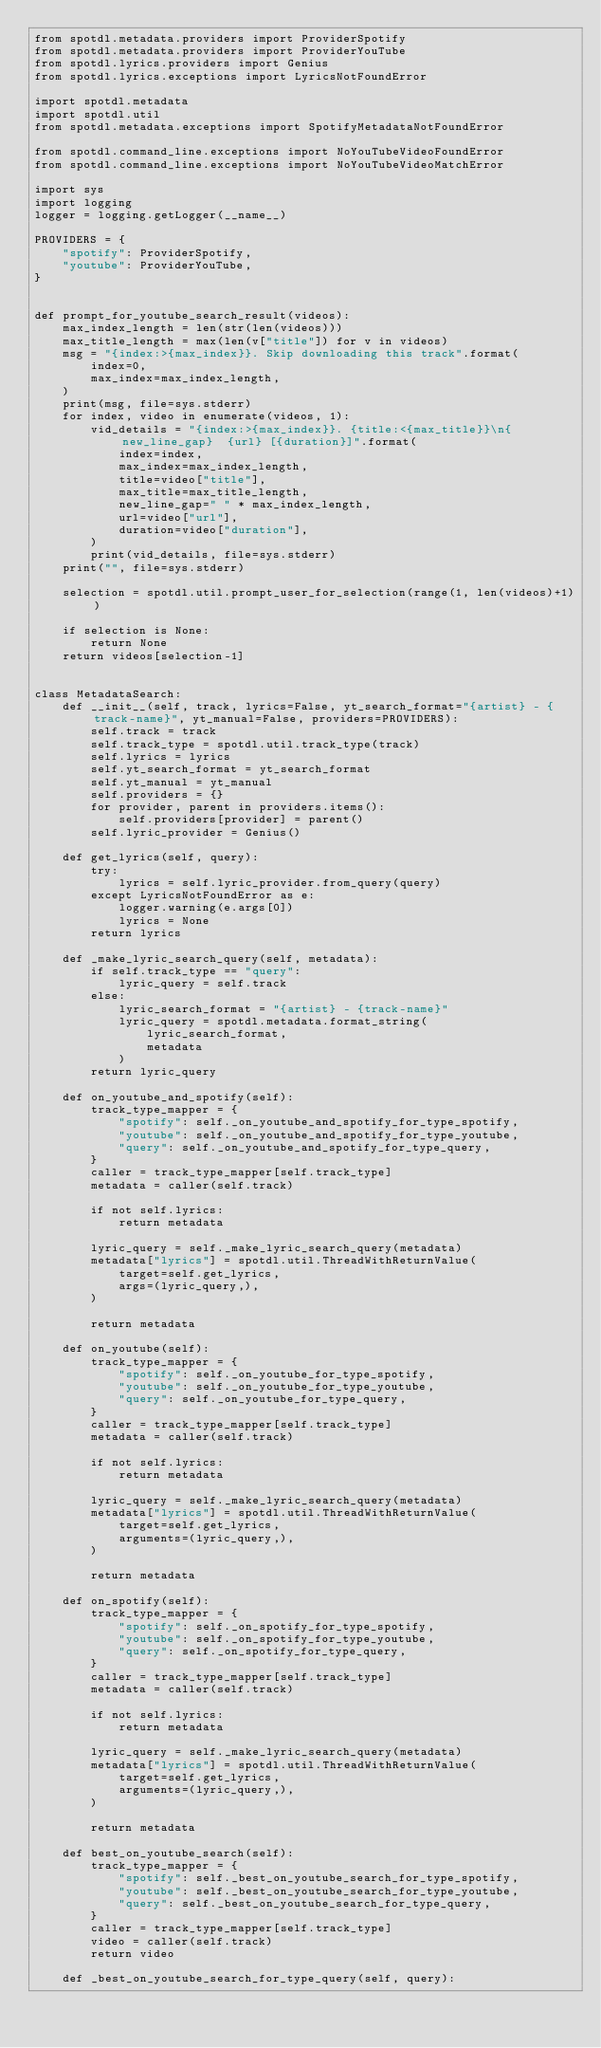Convert code to text. <code><loc_0><loc_0><loc_500><loc_500><_Python_>from spotdl.metadata.providers import ProviderSpotify
from spotdl.metadata.providers import ProviderYouTube
from spotdl.lyrics.providers import Genius
from spotdl.lyrics.exceptions import LyricsNotFoundError

import spotdl.metadata
import spotdl.util
from spotdl.metadata.exceptions import SpotifyMetadataNotFoundError

from spotdl.command_line.exceptions import NoYouTubeVideoFoundError
from spotdl.command_line.exceptions import NoYouTubeVideoMatchError

import sys
import logging
logger = logging.getLogger(__name__)

PROVIDERS = {
    "spotify": ProviderSpotify,
    "youtube": ProviderYouTube,
}


def prompt_for_youtube_search_result(videos):
    max_index_length = len(str(len(videos)))
    max_title_length = max(len(v["title"]) for v in videos)
    msg = "{index:>{max_index}}. Skip downloading this track".format(
        index=0,
        max_index=max_index_length,
    )
    print(msg, file=sys.stderr)
    for index, video in enumerate(videos, 1):
        vid_details = "{index:>{max_index}}. {title:<{max_title}}\n{new_line_gap}  {url} [{duration}]".format(
            index=index,
            max_index=max_index_length,
            title=video["title"],
            max_title=max_title_length,
            new_line_gap=" " * max_index_length,
            url=video["url"],
            duration=video["duration"],
        )
        print(vid_details, file=sys.stderr)
    print("", file=sys.stderr)

    selection = spotdl.util.prompt_user_for_selection(range(1, len(videos)+1))

    if selection is None:
        return None
    return videos[selection-1]


class MetadataSearch:
    def __init__(self, track, lyrics=False, yt_search_format="{artist} - {track-name}", yt_manual=False, providers=PROVIDERS):
        self.track = track
        self.track_type = spotdl.util.track_type(track)
        self.lyrics = lyrics
        self.yt_search_format = yt_search_format
        self.yt_manual = yt_manual
        self.providers = {}
        for provider, parent in providers.items():
            self.providers[provider] = parent()
        self.lyric_provider = Genius()

    def get_lyrics(self, query):
        try:
            lyrics = self.lyric_provider.from_query(query)
        except LyricsNotFoundError as e:
            logger.warning(e.args[0])
            lyrics = None
        return lyrics

    def _make_lyric_search_query(self, metadata):
        if self.track_type == "query":
            lyric_query = self.track
        else:
            lyric_search_format = "{artist} - {track-name}"
            lyric_query = spotdl.metadata.format_string(
                lyric_search_format,
                metadata
            )
        return lyric_query

    def on_youtube_and_spotify(self):
        track_type_mapper = {
            "spotify": self._on_youtube_and_spotify_for_type_spotify,
            "youtube": self._on_youtube_and_spotify_for_type_youtube,
            "query": self._on_youtube_and_spotify_for_type_query,
        }
        caller = track_type_mapper[self.track_type]
        metadata = caller(self.track)

        if not self.lyrics:
            return metadata

        lyric_query = self._make_lyric_search_query(metadata)
        metadata["lyrics"] = spotdl.util.ThreadWithReturnValue(
            target=self.get_lyrics,
            args=(lyric_query,),
        )

        return metadata

    def on_youtube(self):
        track_type_mapper = {
            "spotify": self._on_youtube_for_type_spotify,
            "youtube": self._on_youtube_for_type_youtube,
            "query": self._on_youtube_for_type_query,
        }
        caller = track_type_mapper[self.track_type]
        metadata = caller(self.track)

        if not self.lyrics:
            return metadata

        lyric_query = self._make_lyric_search_query(metadata)
        metadata["lyrics"] = spotdl.util.ThreadWithReturnValue(
            target=self.get_lyrics,
            arguments=(lyric_query,),
        )

        return metadata

    def on_spotify(self):
        track_type_mapper = {
            "spotify": self._on_spotify_for_type_spotify,
            "youtube": self._on_spotify_for_type_youtube,
            "query": self._on_spotify_for_type_query,
        }
        caller = track_type_mapper[self.track_type]
        metadata = caller(self.track)

        if not self.lyrics:
            return metadata

        lyric_query = self._make_lyric_search_query(metadata)
        metadata["lyrics"] = spotdl.util.ThreadWithReturnValue(
            target=self.get_lyrics,
            arguments=(lyric_query,),
        )

        return metadata

    def best_on_youtube_search(self):
        track_type_mapper = {
            "spotify": self._best_on_youtube_search_for_type_spotify,
            "youtube": self._best_on_youtube_search_for_type_youtube,
            "query": self._best_on_youtube_search_for_type_query,
        }
        caller = track_type_mapper[self.track_type]
        video = caller(self.track)
        return video

    def _best_on_youtube_search_for_type_query(self, query):</code> 